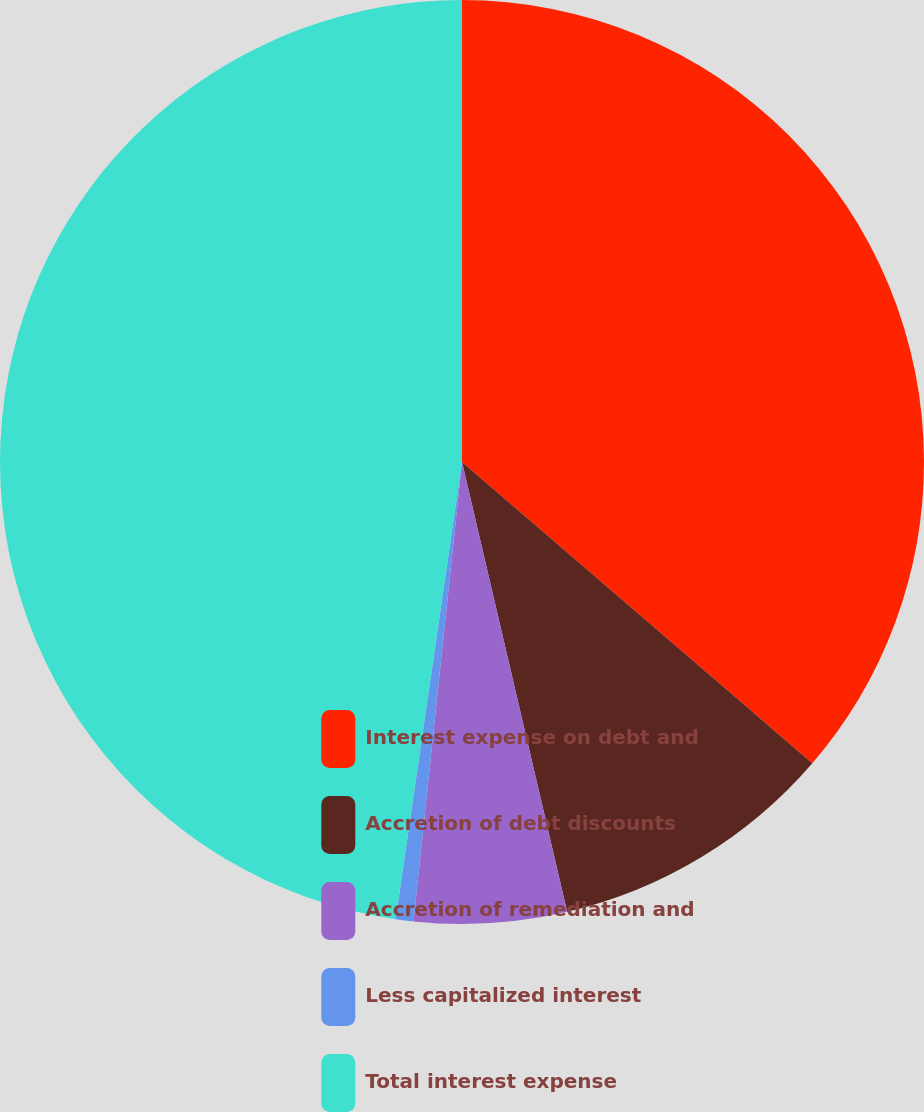Convert chart to OTSL. <chart><loc_0><loc_0><loc_500><loc_500><pie_chart><fcel>Interest expense on debt and<fcel>Accretion of debt discounts<fcel>Accretion of remediation and<fcel>Less capitalized interest<fcel>Total interest expense<nl><fcel>36.3%<fcel>10.04%<fcel>5.33%<fcel>0.62%<fcel>47.7%<nl></chart> 